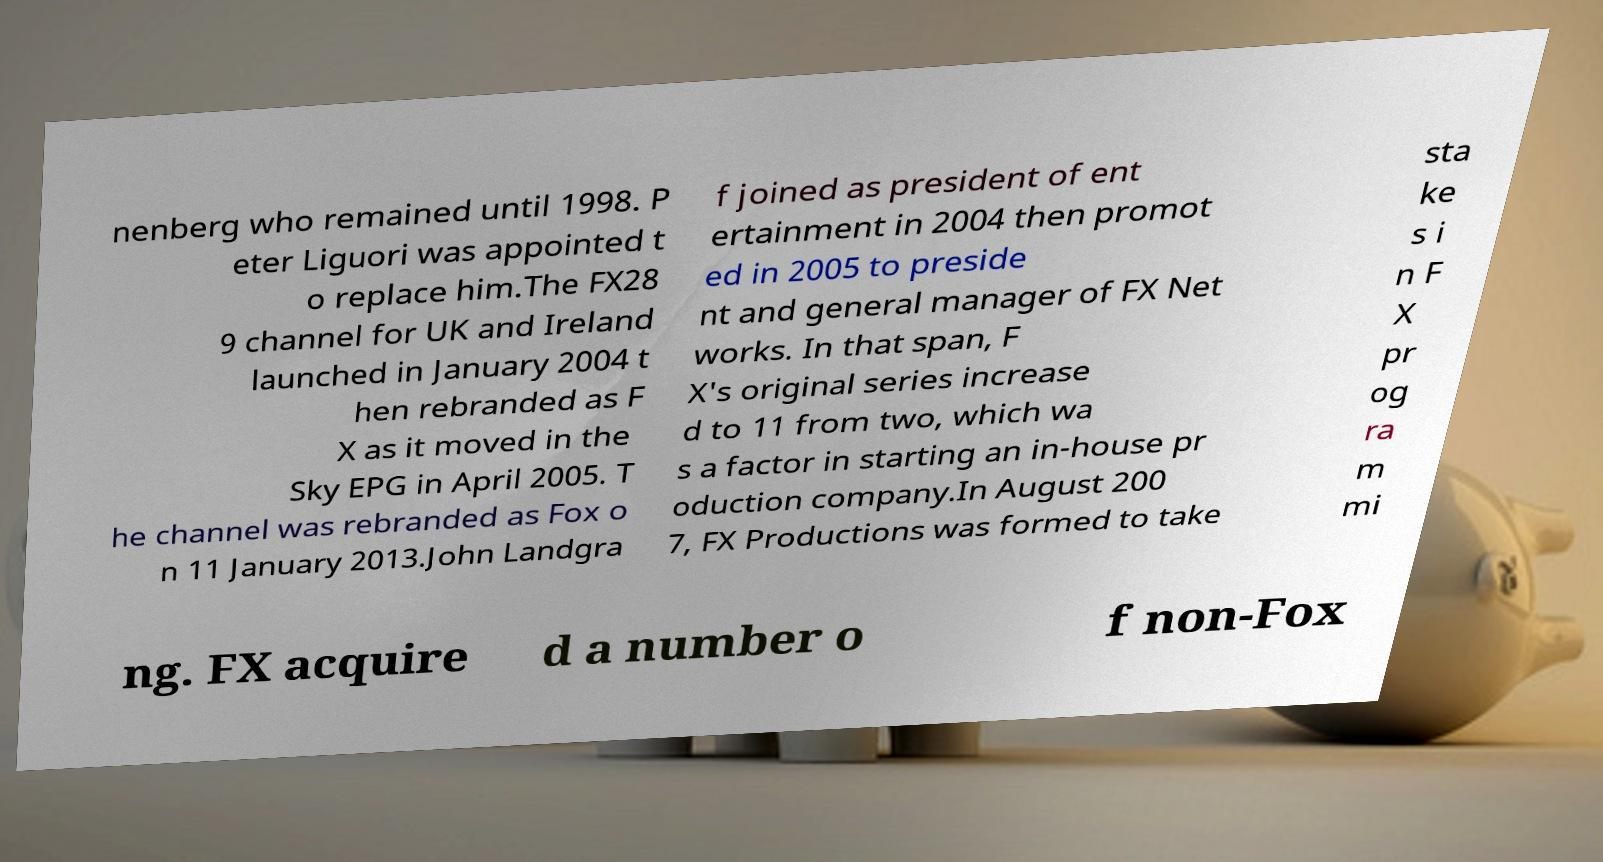There's text embedded in this image that I need extracted. Can you transcribe it verbatim? nenberg who remained until 1998. P eter Liguori was appointed t o replace him.The FX28 9 channel for UK and Ireland launched in January 2004 t hen rebranded as F X as it moved in the Sky EPG in April 2005. T he channel was rebranded as Fox o n 11 January 2013.John Landgra f joined as president of ent ertainment in 2004 then promot ed in 2005 to preside nt and general manager of FX Net works. In that span, F X's original series increase d to 11 from two, which wa s a factor in starting an in-house pr oduction company.In August 200 7, FX Productions was formed to take sta ke s i n F X pr og ra m mi ng. FX acquire d a number o f non-Fox 